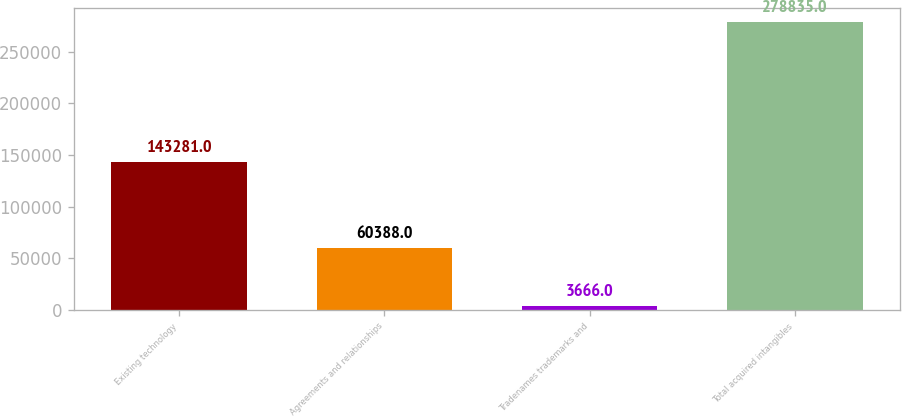Convert chart to OTSL. <chart><loc_0><loc_0><loc_500><loc_500><bar_chart><fcel>Existing technology<fcel>Agreements and relationships<fcel>Tradenames trademarks and<fcel>Total acquired intangibles<nl><fcel>143281<fcel>60388<fcel>3666<fcel>278835<nl></chart> 